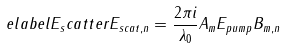<formula> <loc_0><loc_0><loc_500><loc_500>\ e l a b e l { E _ { s } c a t t e r } E _ { s c a t , n } = \frac { 2 \pi i } { \lambda _ { 0 } } A _ { m } E _ { p u m p } B _ { m , n }</formula> 